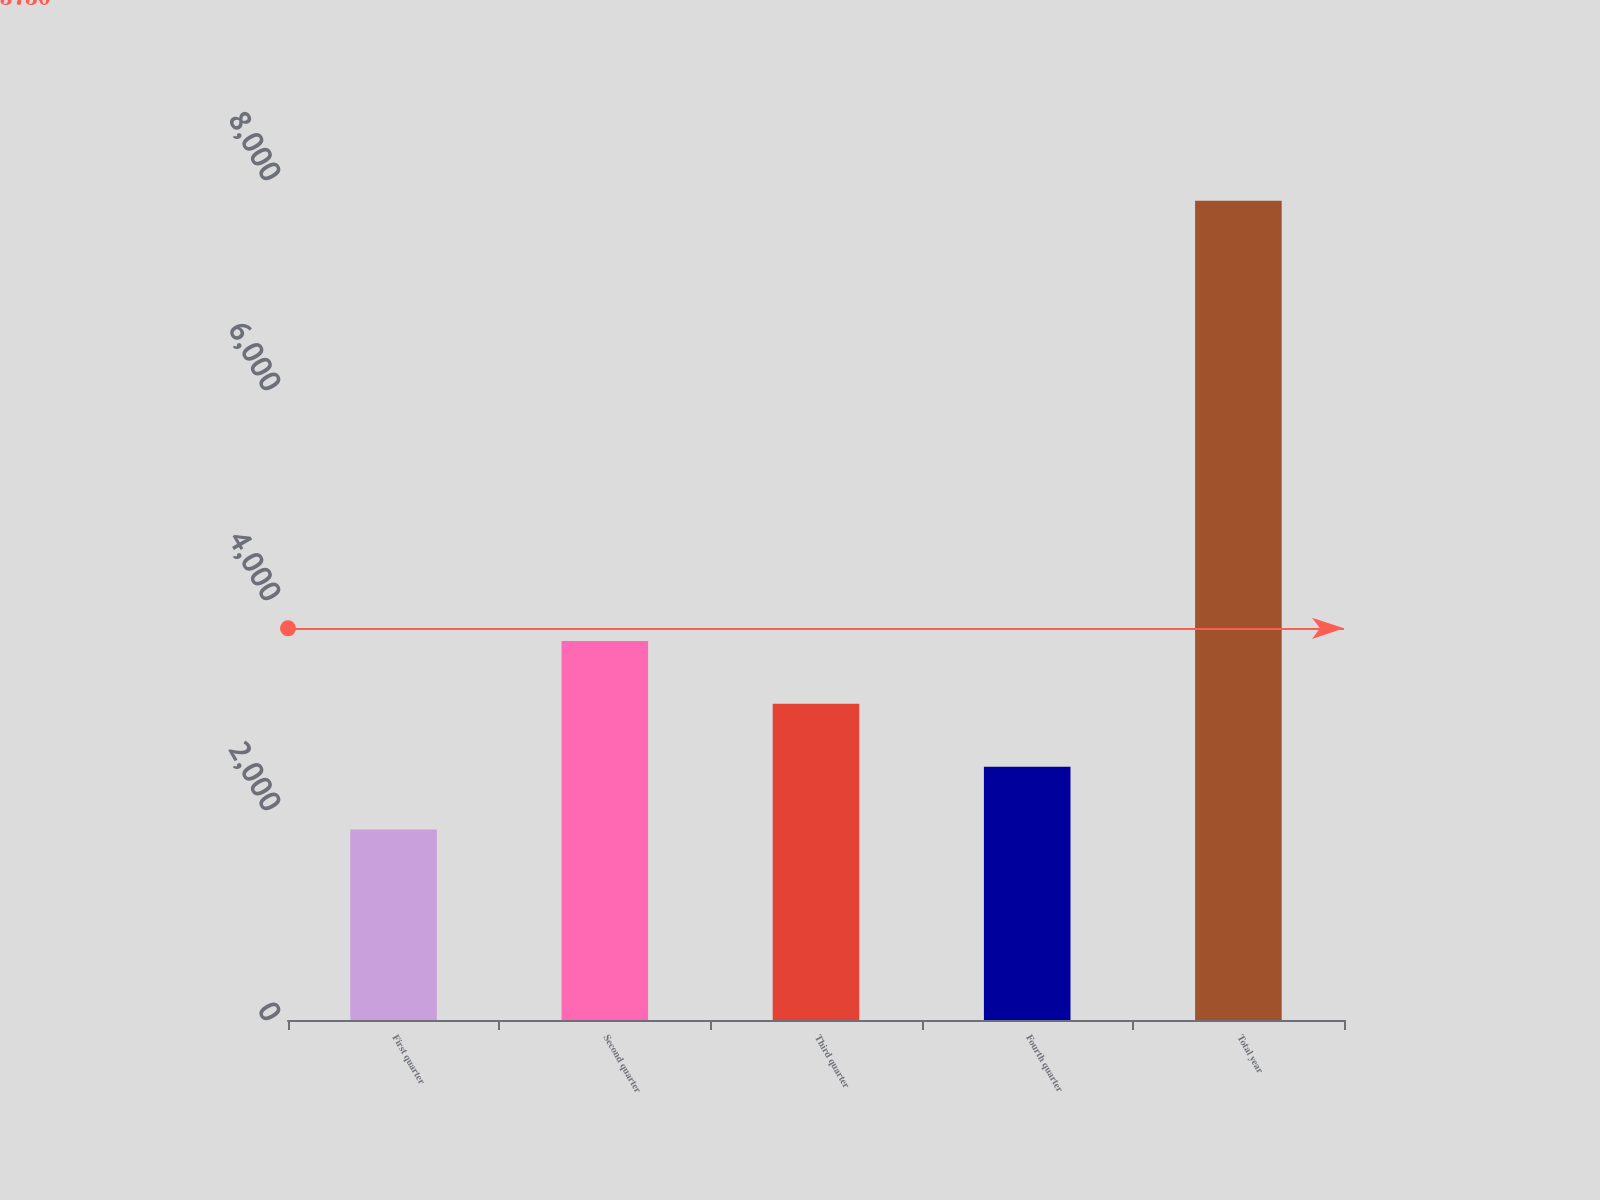Convert chart. <chart><loc_0><loc_0><loc_500><loc_500><bar_chart><fcel>First quarter<fcel>Second quarter<fcel>Third quarter<fcel>Fourth quarter<fcel>Total year<nl><fcel>1813.1<fcel>3610.19<fcel>3011.16<fcel>2412.13<fcel>7803.4<nl></chart> 